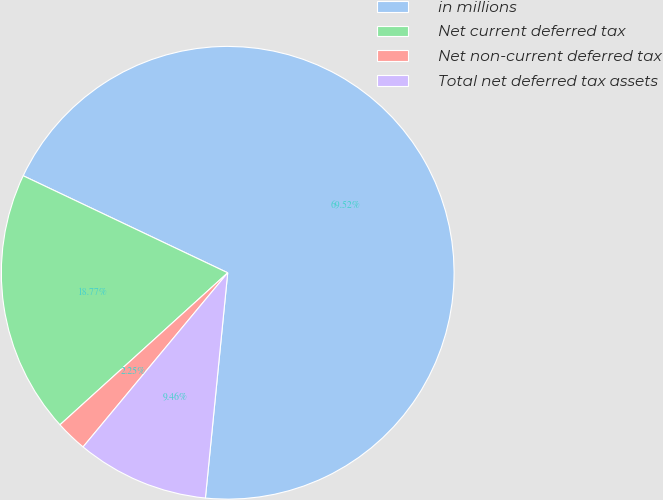<chart> <loc_0><loc_0><loc_500><loc_500><pie_chart><fcel>in millions<fcel>Net current deferred tax<fcel>Net non-current deferred tax<fcel>Total net deferred tax assets<nl><fcel>69.52%<fcel>18.77%<fcel>2.25%<fcel>9.46%<nl></chart> 